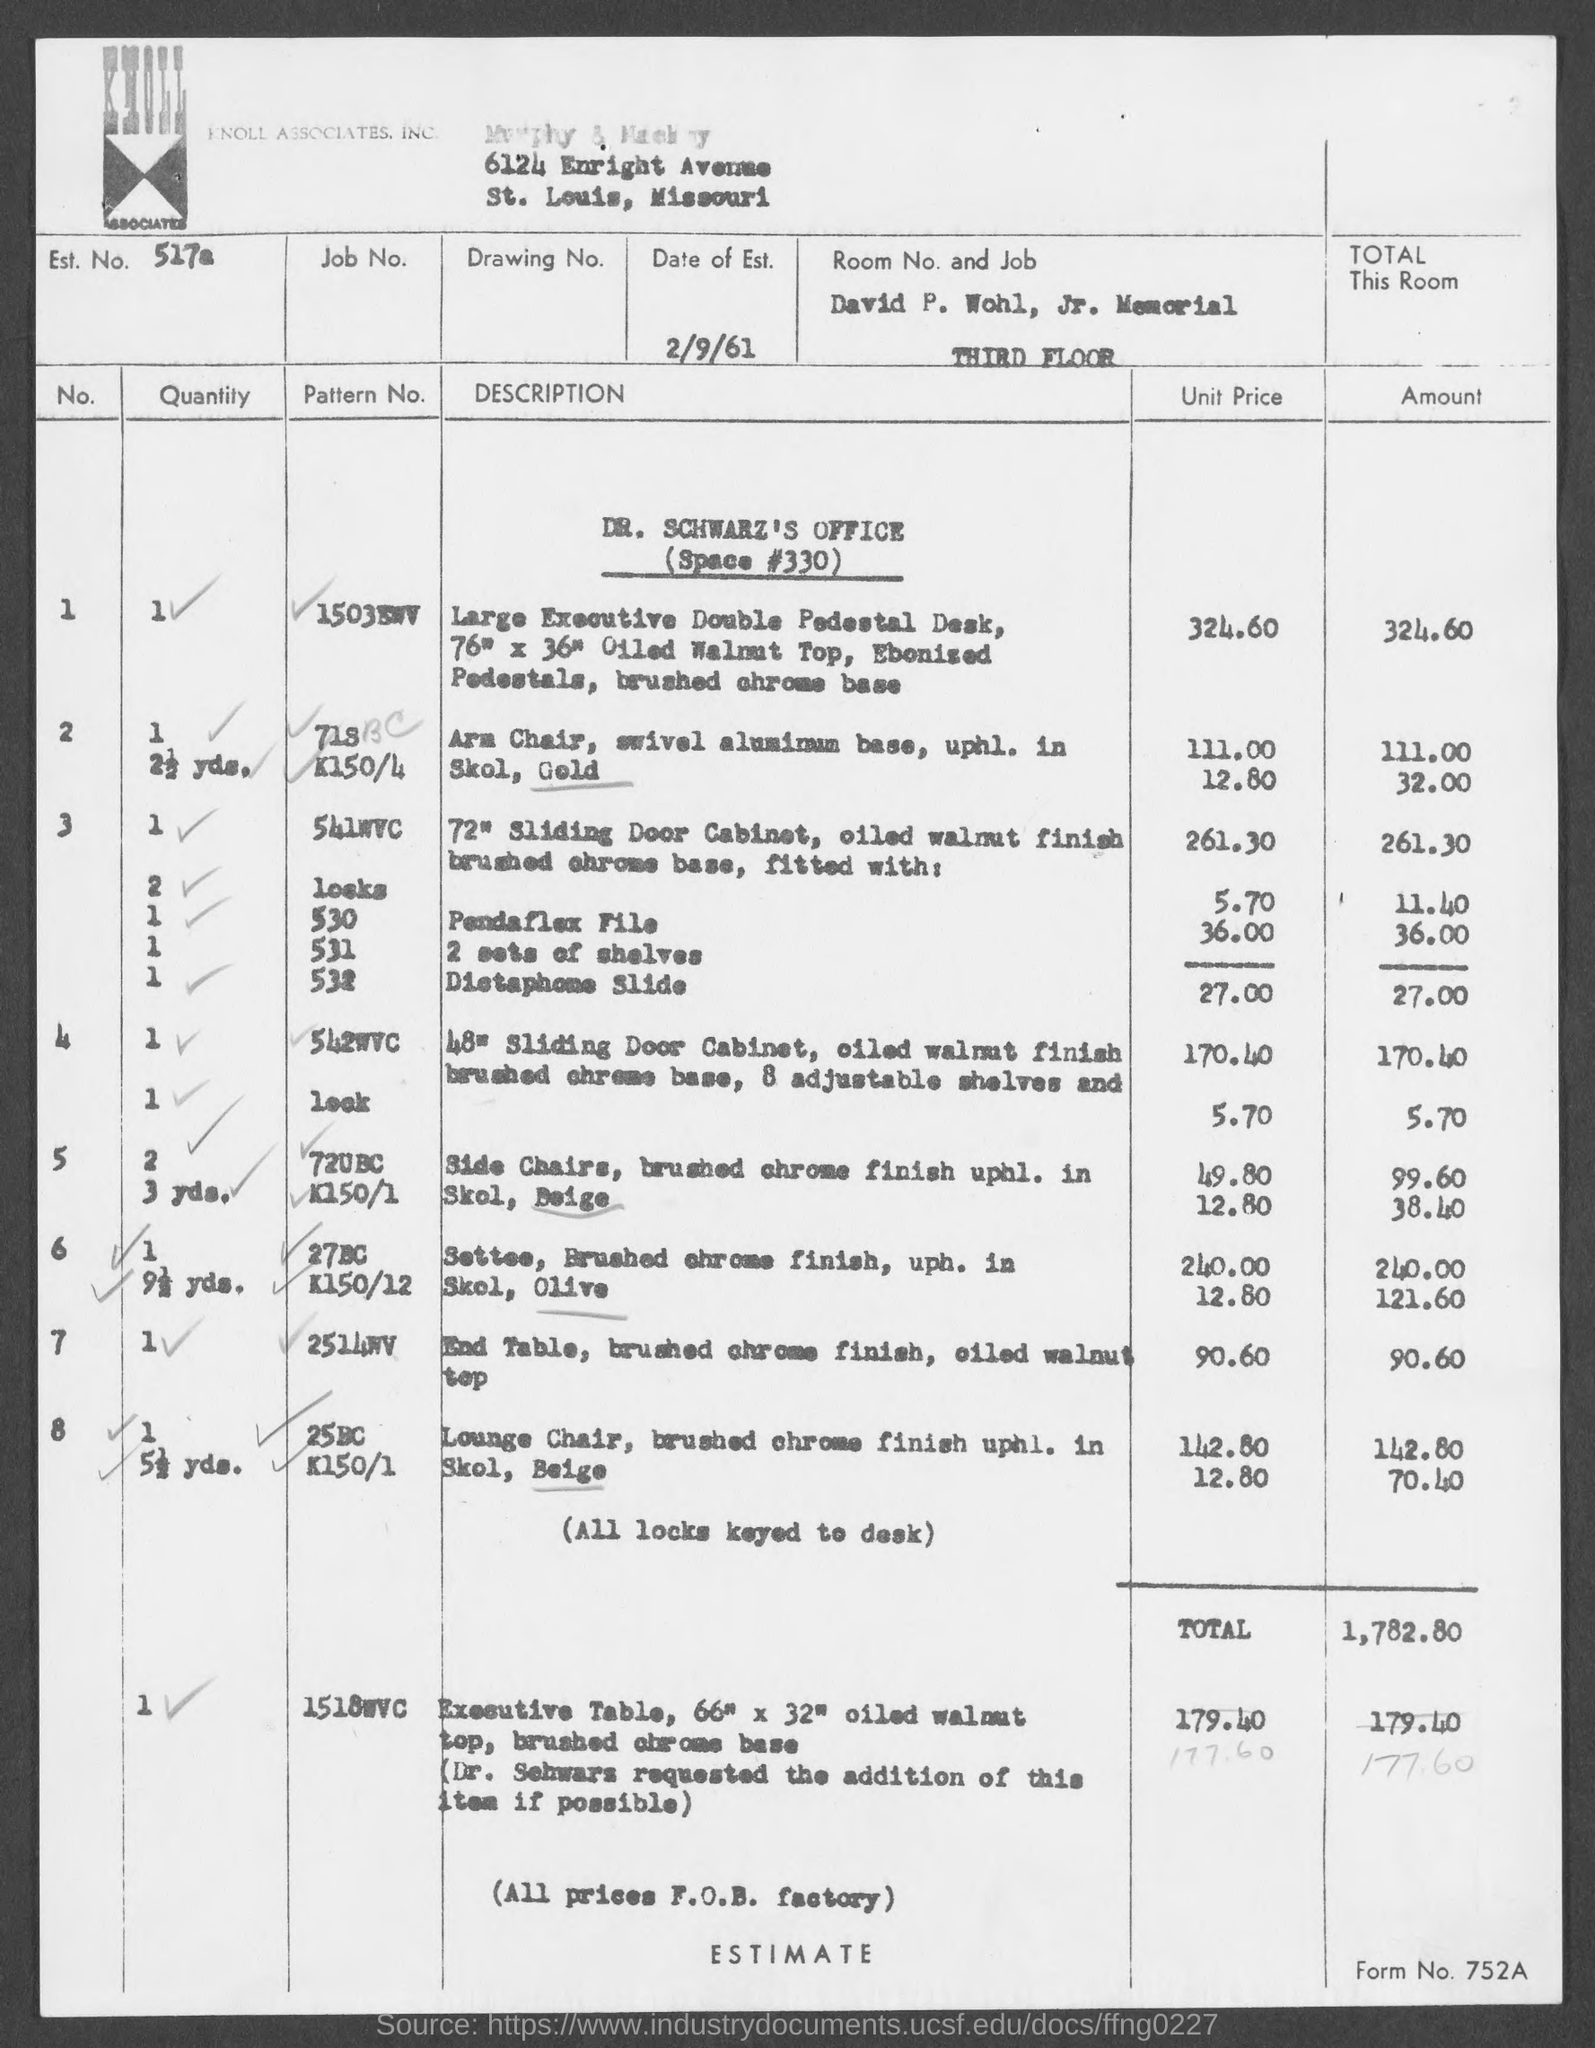Draw attention to some important aspects in this diagram. The date of establishment mentioned in the document is February 9, 1961. According to the document, an Est. No. of 517a has been provided. The estimated total amount for Dr. Schwarz's Office (Space #330) is 1,782.8... The document contains a Form No. of 752a. 